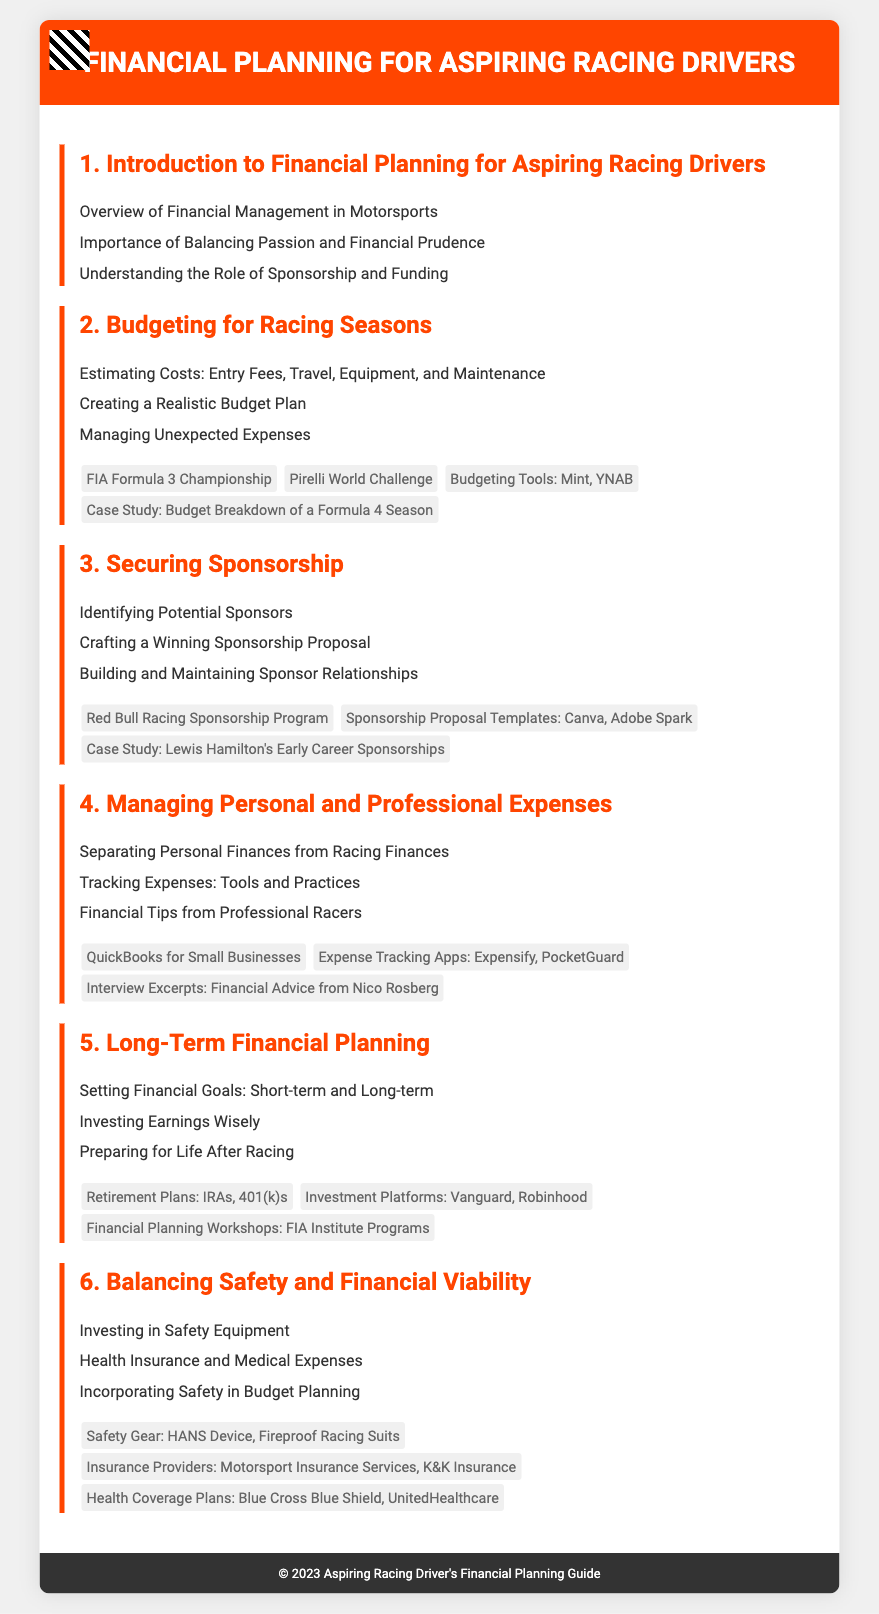what is the first topic of the syllabus? The first topic is the initial focus or section listed in the syllabus, highlighting the theme of financial planning for racing drivers.
Answer: Introduction to Financial Planning for Aspiring Racing Drivers how many main topics are covered in the syllabus? The syllabus outlines several sections or units that address different aspects of financial planning.
Answer: Six which budgeting tool is mentioned in the syllabus? The syllabus lists specific tools that can assist in budgeting for racing expenses, indicating recommended resources.
Answer: Mint, YNAB what is included in the section about securing sponsorship? This section outlines what is necessary for aspiring drivers, covering the specific actions to take to establish sponsorships.
Answer: Identifying Potential Sponsors who's case study is referenced in the sponsorship section? The document includes real-life examples to illustrate key concepts, such as successful sponsorship acquisition in racing careers.
Answer: Lewis Hamilton's Early Career Sponsorships what should aspiring drivers invest in according to the syllabus? The syllabus emphasizes the importance of safety in the racing profession, stating necessary expenditures drivers should consider.
Answer: Safety Equipment what is the focus of the last topic in the syllabus? The last section of the syllabus aims to highlight the significance of integrating safety into the financial considerations of racing.
Answer: Balancing Safety and Financial Viability what is mentioned as a financial planning tool in the syllabus? Among various tools presented in the document, this one is recommended for managing personal finances effectively.
Answer: QuickBooks for Small Businesses 